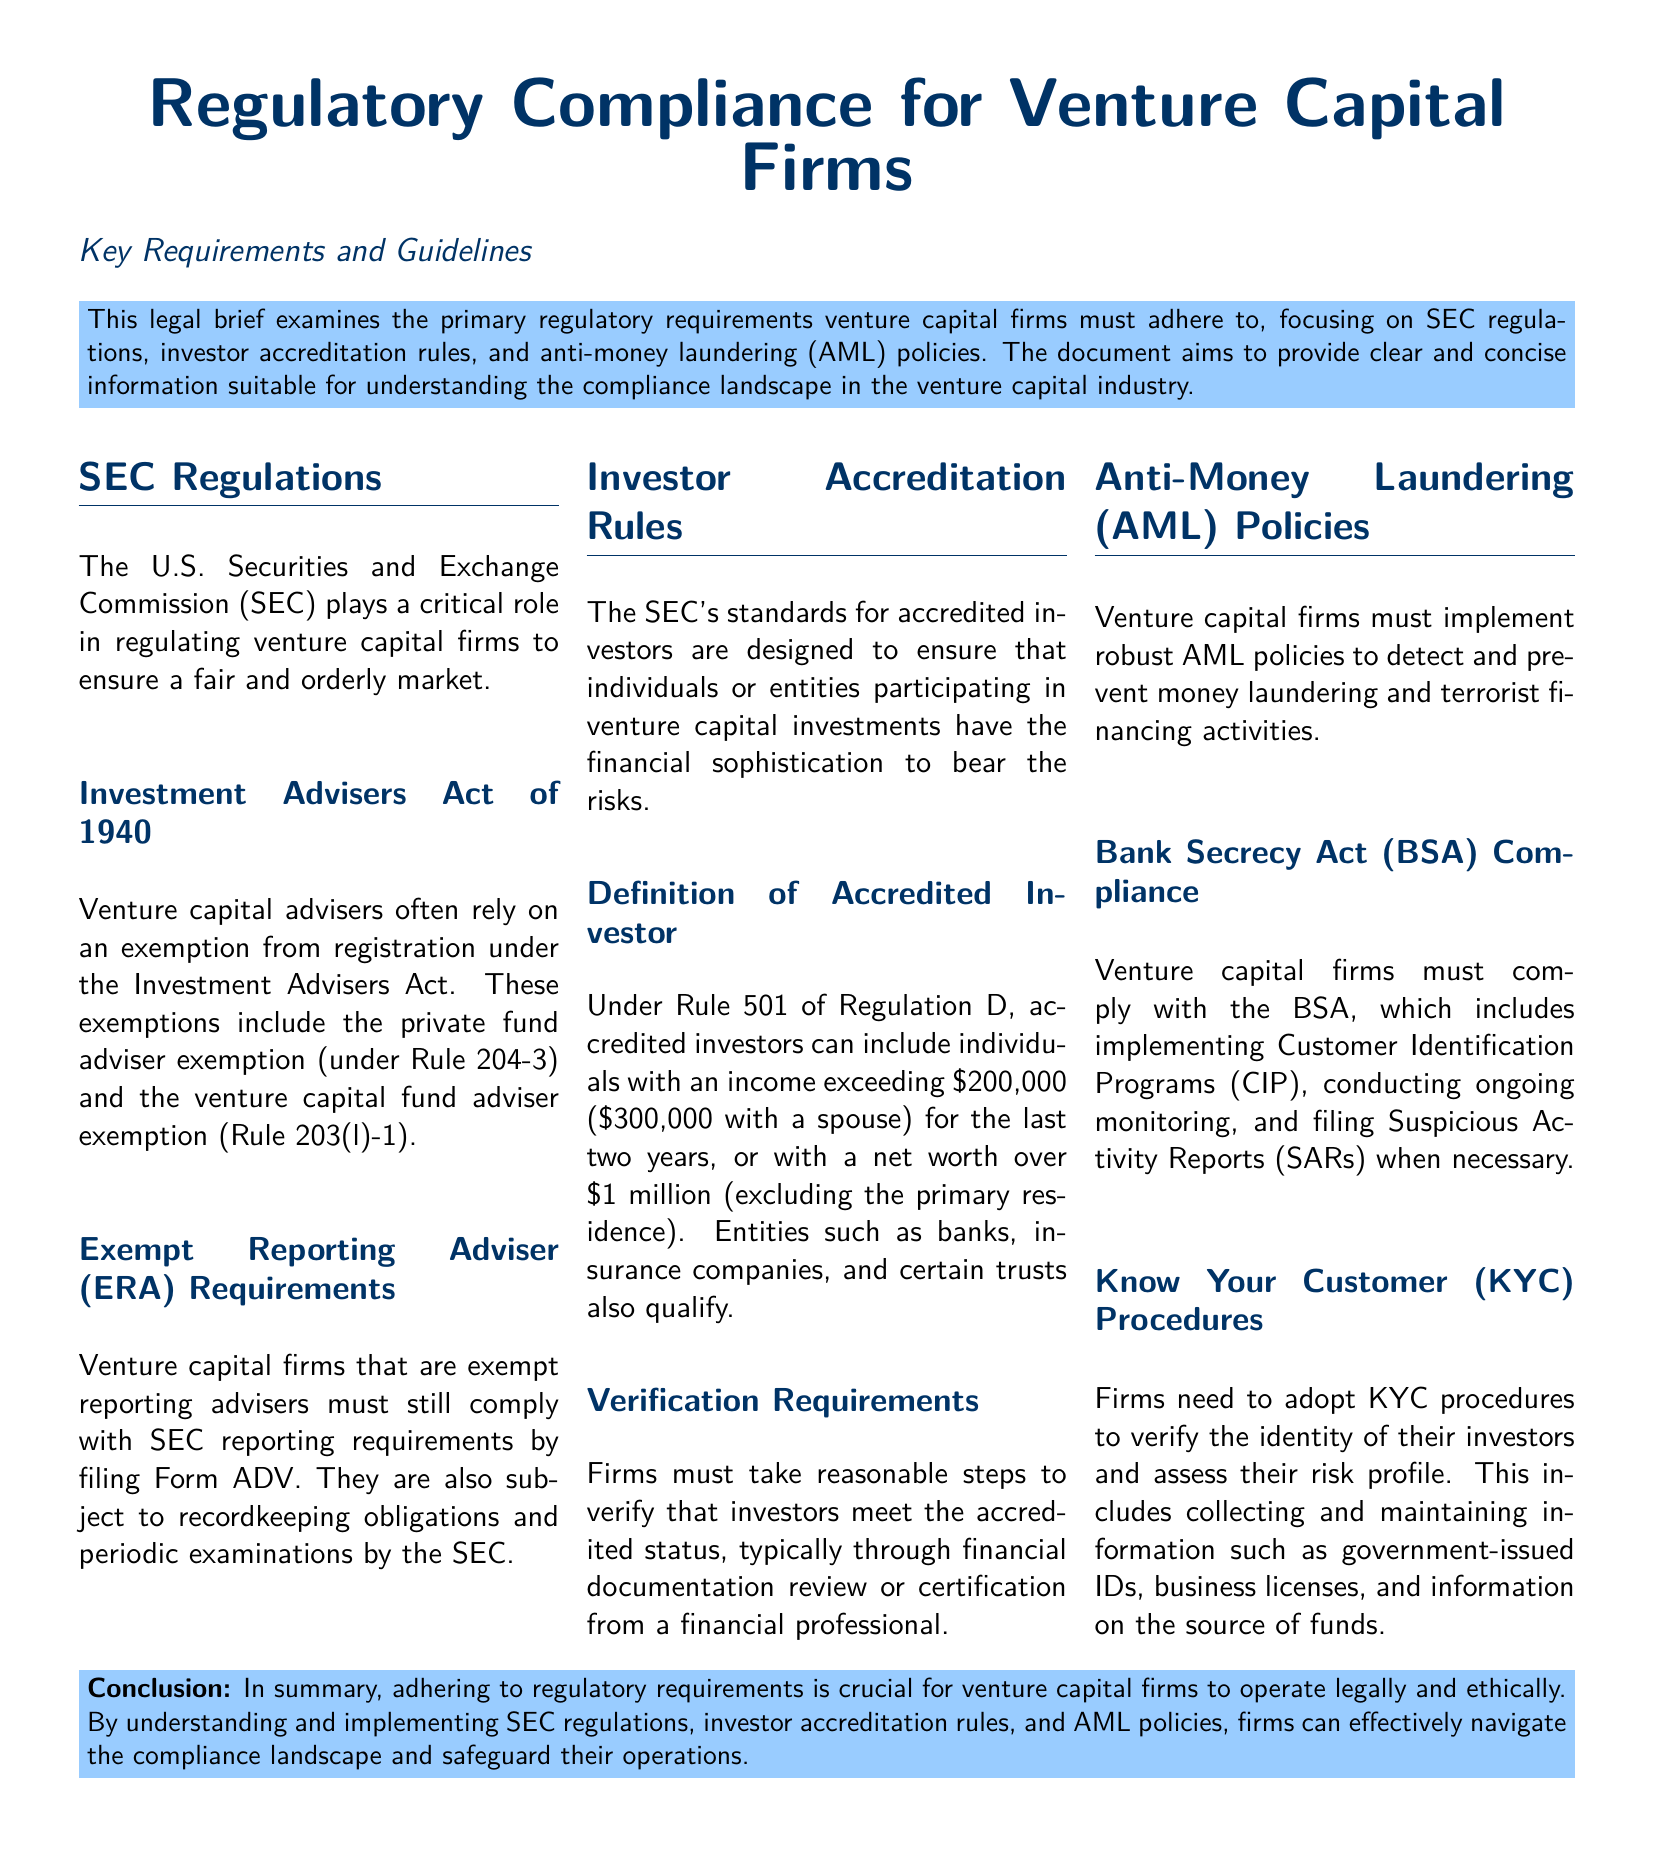What role does the SEC play in venture capital regulation? The SEC regulates venture capital firms to ensure a fair and orderly market.
Answer: Regulator What is the exemption that venture capital advisers often rely on? Venture capital advisers often rely on an exemption from registration under the Investment Advisers Act.
Answer: Exemption What is the income threshold for an accredited investor? Individuals must have an income exceeding $200,000 ($300,000 with a spouse) for the last two years.
Answer: $200,000 What must exempt reporting advisers file with the SEC? Exempt reporting advisers must file Form ADV.
Answer: Form ADV What act requires venture capital firms to implement AML policies? The Bank Secrecy Act (BSA) requires compliance with AML policies.
Answer: Bank Secrecy Act What does KYC stand for in the context of AML policies? KYC stands for Know Your Customer.
Answer: Know Your Customer What is one of the main requirements for verifying accredited investors? Firms must take reasonable steps to verify accredited status.
Answer: Reasonable steps What kind of monitoring do venture capital firms need to conduct under BSA compliance? Ongoing monitoring is part of BSA compliance.
Answer: Ongoing monitoring What are firms required to file when they detect suspicious activities? Firms must file Suspicious Activity Reports (SARs) when necessary.
Answer: Suspicious Activity Reports 